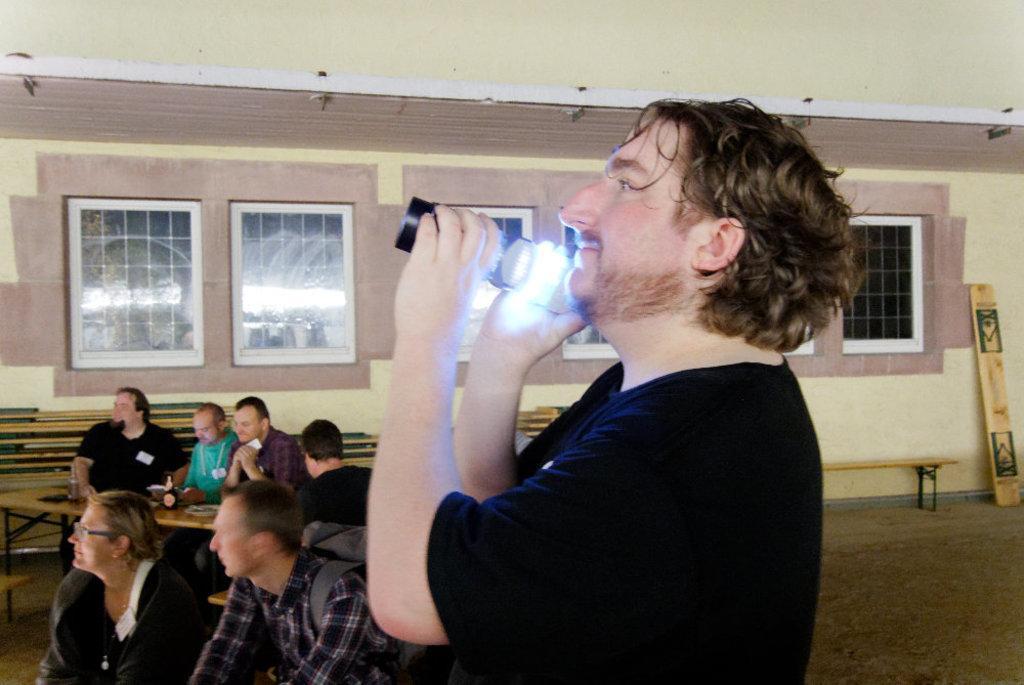Could you give a brief overview of what you see in this image? In this picture I can see a person standing and holding a torch light. I can see little people sitting on benches. I can see the wall with the windows in the background. 